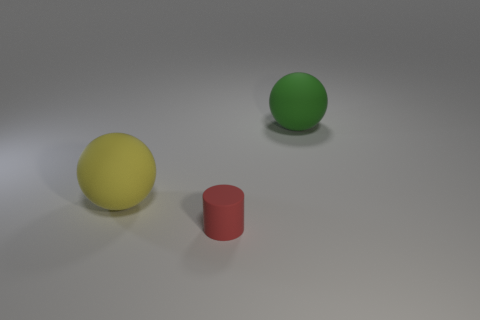Add 3 big yellow rubber objects. How many objects exist? 6 Subtract all balls. How many objects are left? 1 Subtract all large green matte spheres. Subtract all small cylinders. How many objects are left? 1 Add 2 yellow spheres. How many yellow spheres are left? 3 Add 1 tiny rubber cylinders. How many tiny rubber cylinders exist? 2 Subtract 0 purple blocks. How many objects are left? 3 